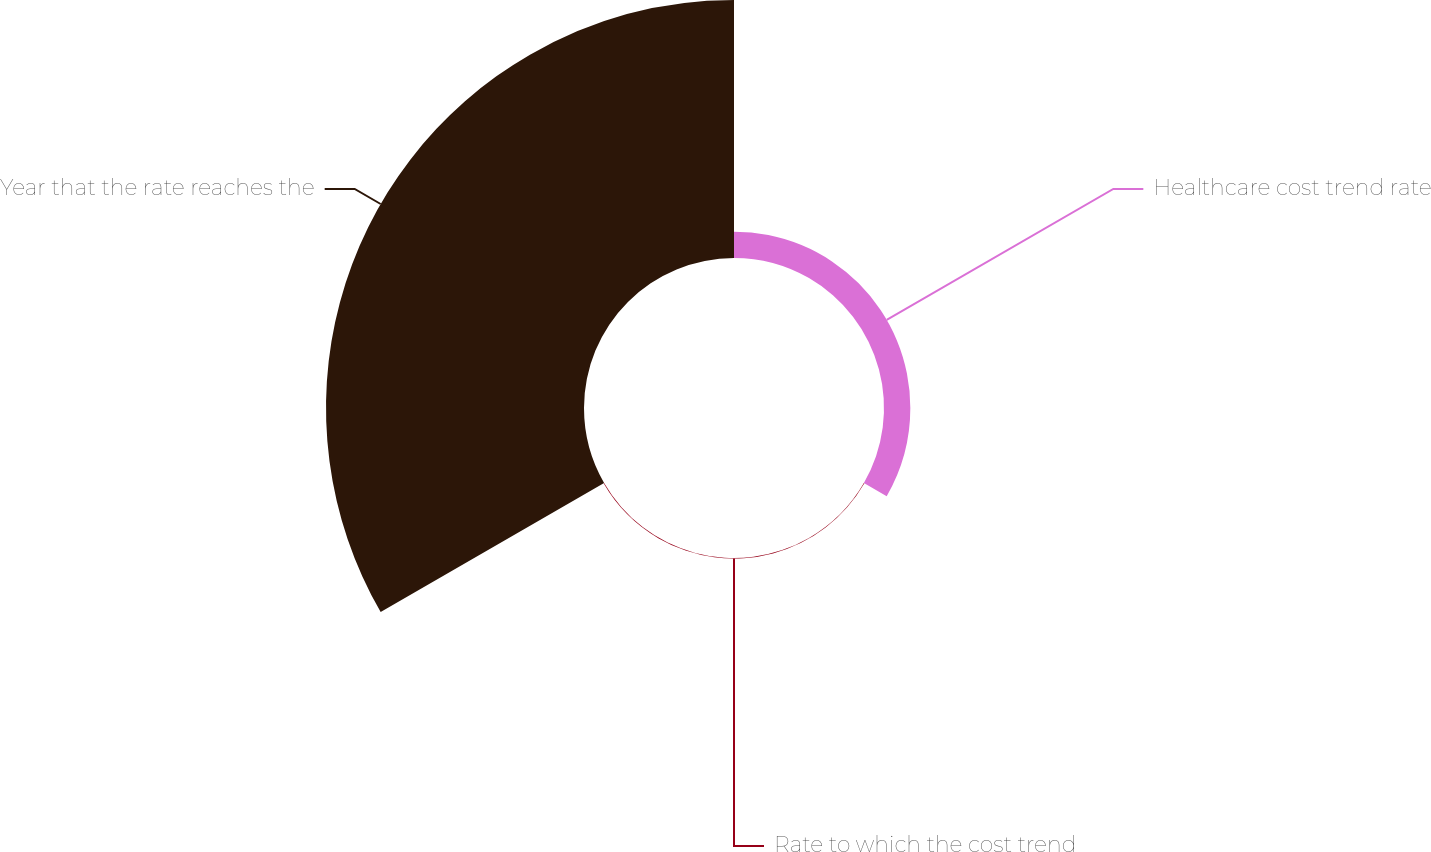Convert chart. <chart><loc_0><loc_0><loc_500><loc_500><pie_chart><fcel>Healthcare cost trend rate<fcel>Rate to which the cost trend<fcel>Year that the rate reaches the<nl><fcel>9.24%<fcel>0.2%<fcel>90.56%<nl></chart> 